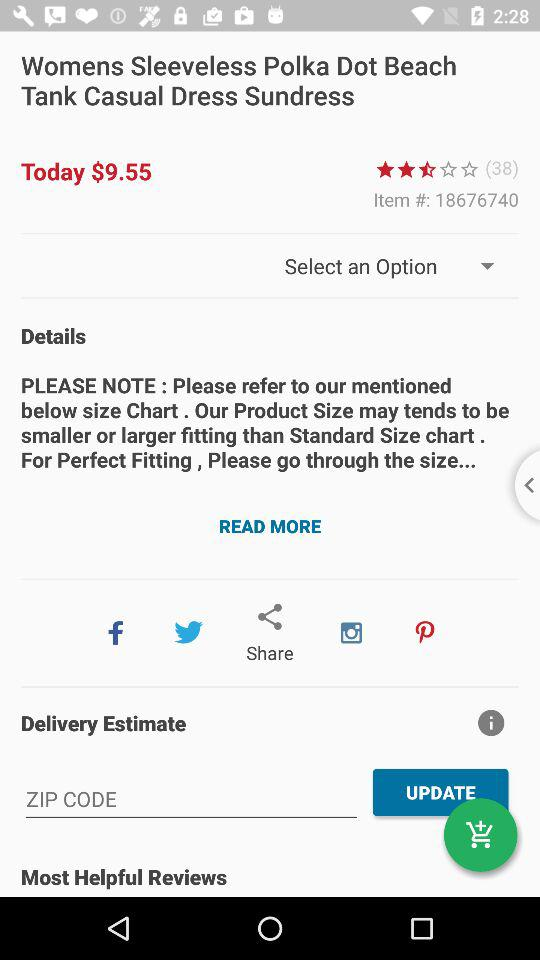What is the zip code?
When the provided information is insufficient, respond with <no answer>. <no answer> 